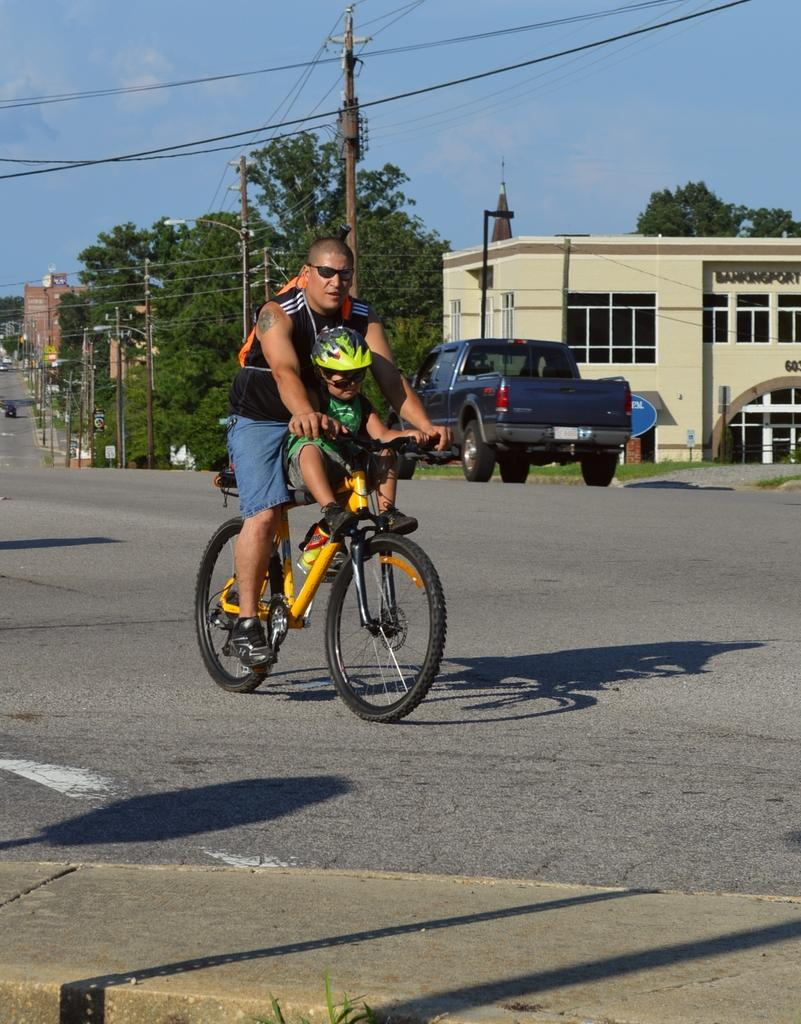What is the man in the image doing? The man is riding a bicycle in the image. Where is the man riding the bicycle? The man is on the road in the image. What can be seen in the background of the image? There are trees visible in the image. What else is present on the road in the image? There is a vehicle in the image. What type of structures can be seen in the image? There are buildings in the image. What type of receipt can be seen in the man's hand while riding the bicycle? There is no receipt visible in the man's hand or anywhere in the image. What type of machine is the man using to ride the bicycle? The man is riding a traditional bicycle, which does not require a machine to operate. 